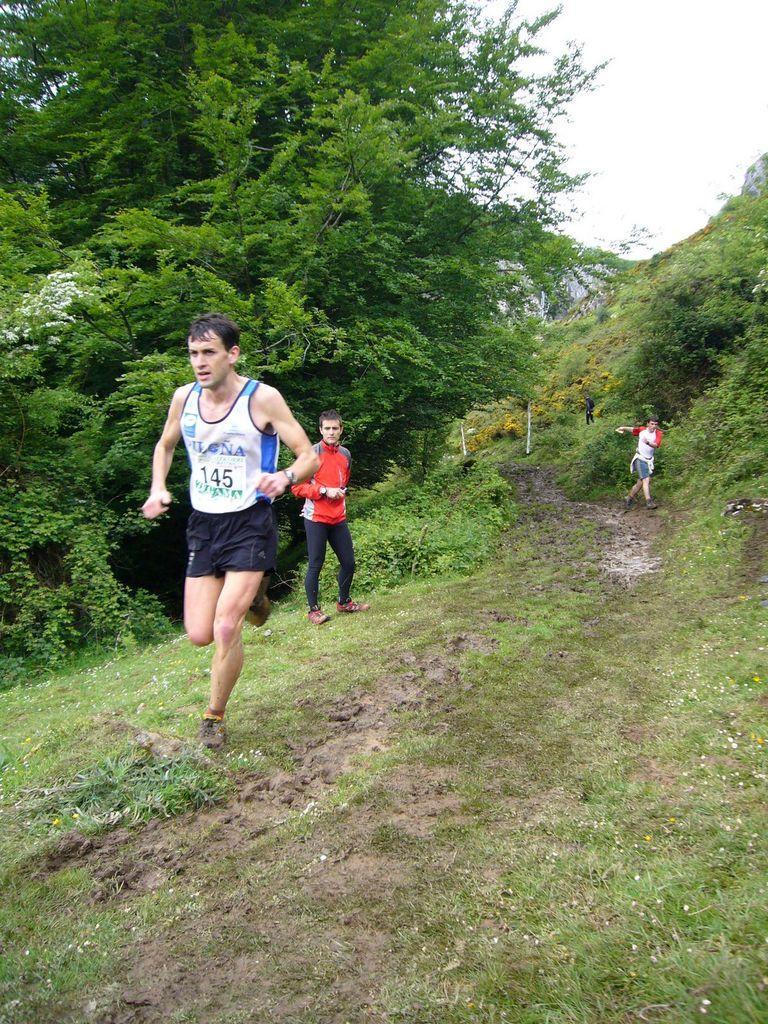What are the two persons in the image doing? The two persons in the image are running. Can you describe the person who is not running in the image? There is a person standing on the grass in the image. What type of natural environment is visible in the image? There are trees and plants in the image. What can be seen in the background of the image? The sky is visible in the background of the image. How many coils can be seen in the image? There are no coils present in the image. What type of giants are interacting with the trees in the image? There are no giants present in the image; it features two persons running and a person standing on the grass. 